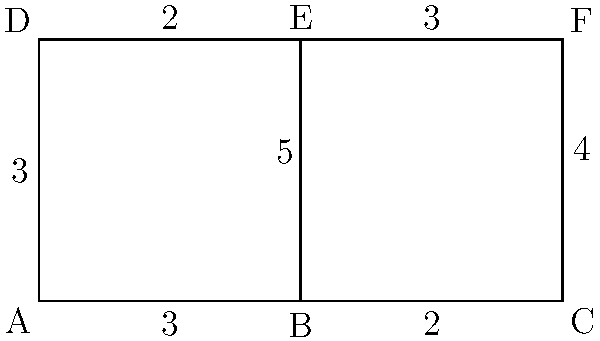A warehouse manager wants to optimize the layout for efficient product movement. The graph represents different sections of the warehouse, with edges showing connections and weights indicating travel time (in minutes) between sections. What is the minimum time required to visit all sections, starting and ending at section A, without revisiting any section? To solve this problem, we need to find the Hamiltonian cycle with the minimum total weight. Here's a step-by-step approach:

1. Identify all possible Hamiltonian cycles starting and ending at A:
   - A-B-C-F-E-D-A
   - A-D-E-F-C-B-A

2. Calculate the total weight (time) for each cycle:
   - A-B-C-F-E-D-A: 3 + 2 + 4 + 3 + 2 + 3 = 17 minutes
   - A-D-E-F-C-B-A: 3 + 2 + 3 + 4 + 2 + 3 = 17 minutes

3. Compare the total weights:
   Both cycles have the same total weight of 17 minutes.

4. Choose either cycle as the optimal solution, as they both provide the minimum time.

Therefore, the minimum time required to visit all sections, starting and ending at A, without revisiting any section is 17 minutes.
Answer: 17 minutes 